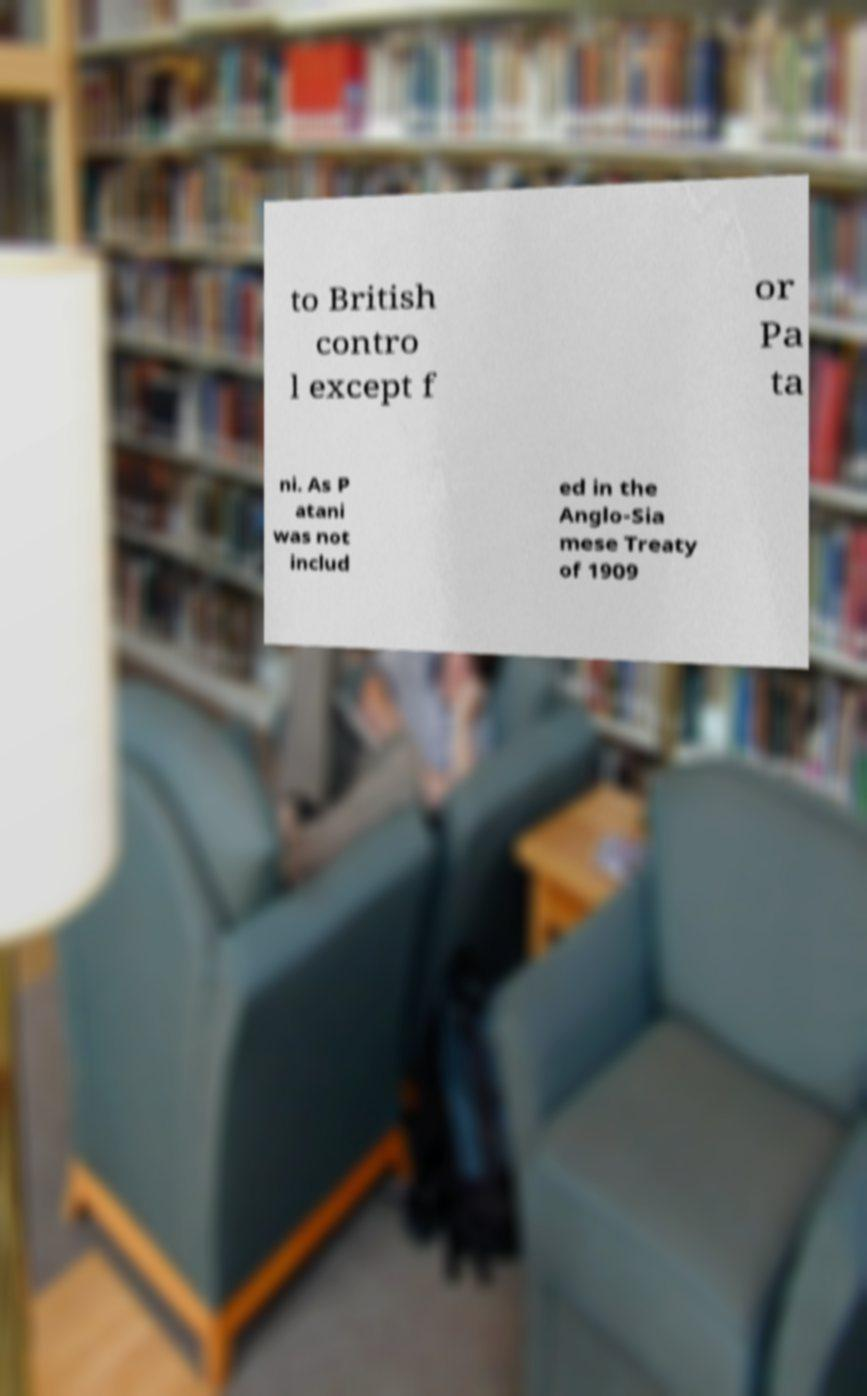Please read and relay the text visible in this image. What does it say? to British contro l except f or Pa ta ni. As P atani was not includ ed in the Anglo-Sia mese Treaty of 1909 